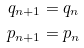<formula> <loc_0><loc_0><loc_500><loc_500>q _ { n + 1 } & = q _ { n } \\ p _ { n + 1 } & = p _ { n }</formula> 